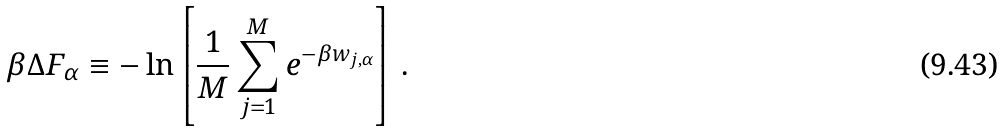<formula> <loc_0><loc_0><loc_500><loc_500>\beta \Delta F _ { \alpha } \equiv - \ln \left [ \frac { 1 } { M } \sum _ { j = 1 } ^ { M } e ^ { - \beta w _ { j , \alpha } } \right ] \, .</formula> 